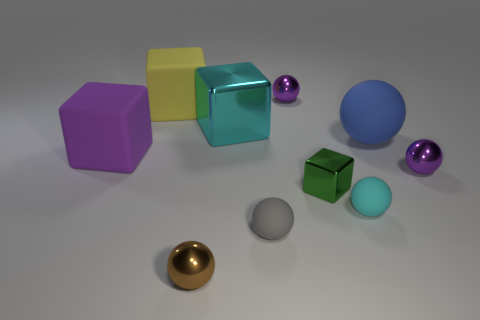Subtract all tiny cyan matte balls. How many balls are left? 5 Subtract all purple balls. How many balls are left? 4 Subtract 1 cubes. How many cubes are left? 3 Subtract all spheres. How many objects are left? 4 Subtract all cyan cubes. Subtract all purple spheres. How many cubes are left? 3 Subtract all cyan cylinders. How many gray spheres are left? 1 Subtract all gray metallic balls. Subtract all purple rubber things. How many objects are left? 9 Add 1 blue spheres. How many blue spheres are left? 2 Add 3 big cyan cubes. How many big cyan cubes exist? 4 Subtract 0 gray cubes. How many objects are left? 10 